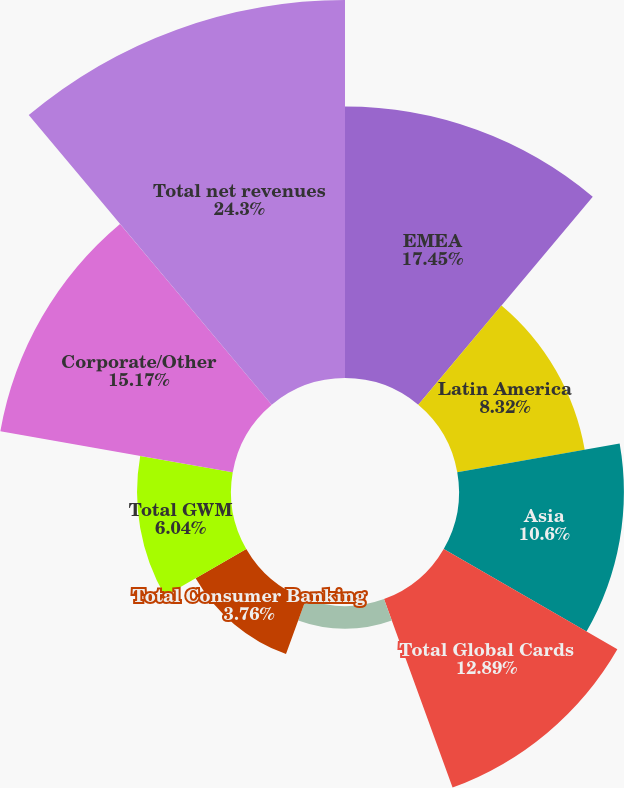Convert chart to OTSL. <chart><loc_0><loc_0><loc_500><loc_500><pie_chart><fcel>EMEA<fcel>Latin America<fcel>Asia<fcel>Total Global Cards<fcel>North America<fcel>Total Consumer Banking<fcel>Total GWM<fcel>Corporate/Other<fcel>Total net revenues<nl><fcel>17.45%<fcel>8.32%<fcel>10.6%<fcel>12.89%<fcel>1.47%<fcel>3.76%<fcel>6.04%<fcel>15.17%<fcel>24.3%<nl></chart> 